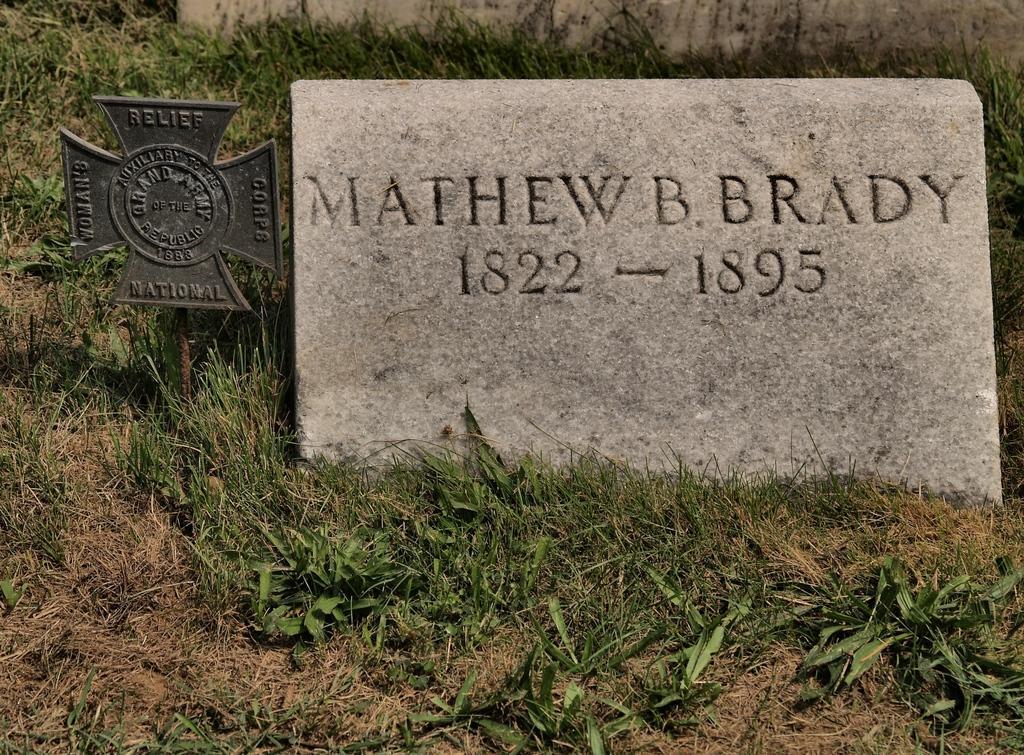Describe this image in one or two sentences. This image is taken outdoors. At the bottom of the image there is a ground with grass on it. In the middle of the image there is a tombstone with a text on it. There is a metal board with a text on it. At the top of the image there is a wall. 